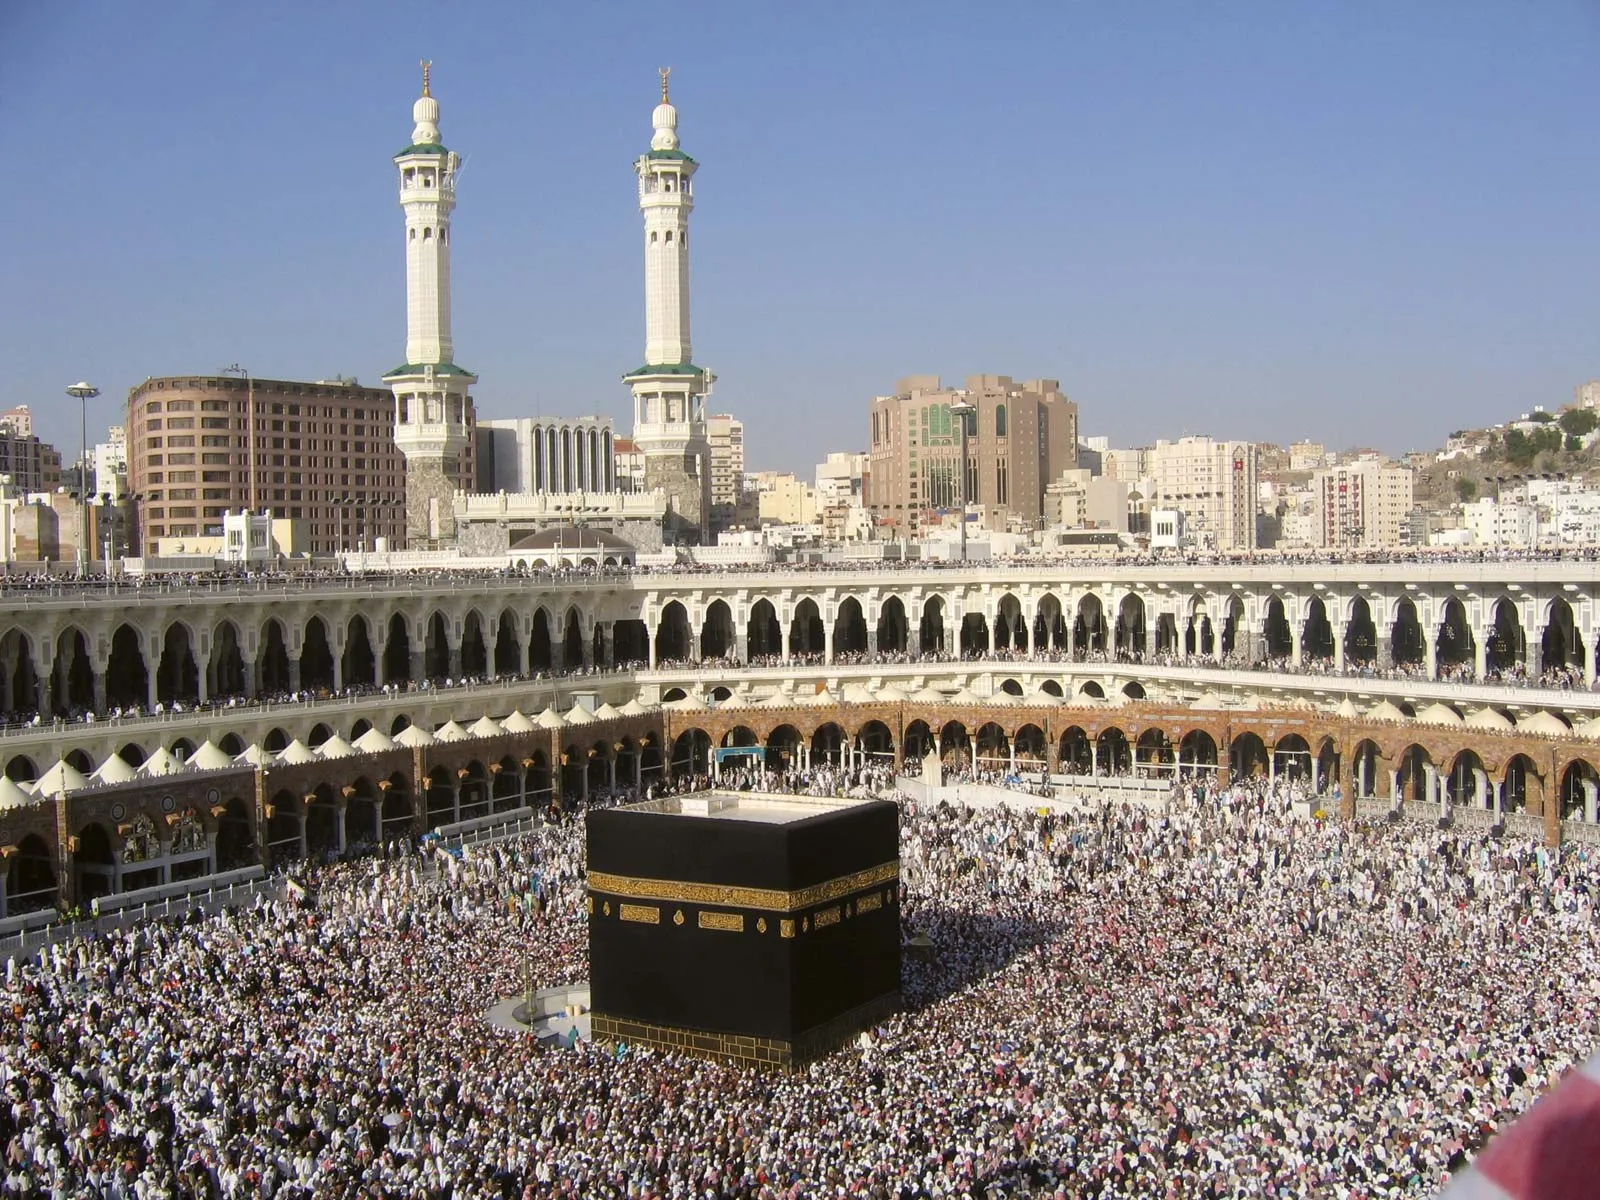What role do the surrounding structures play during Hajj? The surrounding structures, including the arcades and minarets, serve multiple important functions during Hajj. The arcades provide shade and space for pilgrims to pray and rest, protecting them from the harsh sun. The minarets are used to call pilgrims to prayer, serving a crucial role in coordinating the activities of millions of pilgrims. Additionally, the towering minarets help pilgrims in navigating the area, acting as prominent landmarks within the vast assembly. 